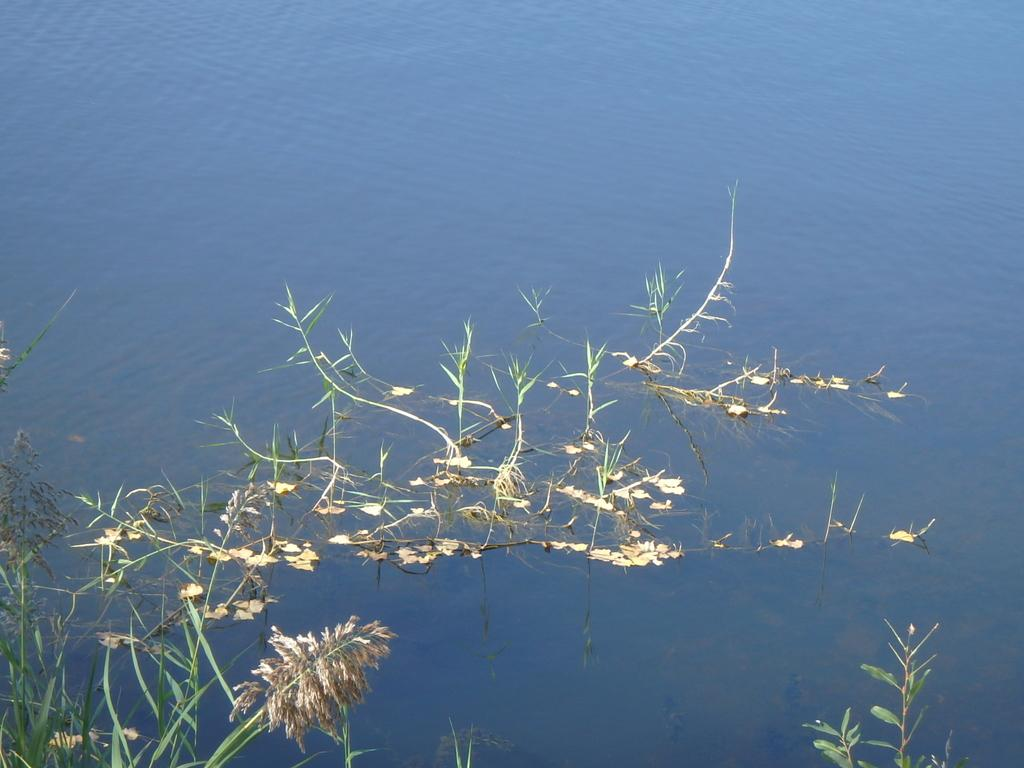What type of living organisms can be seen in the image? Plants can be seen in the image. What is visible at the bottom of the image? There is water visible at the bottom of the image. How does the trick work in the image? There is no trick present in the image; it simply contains plants and water. 